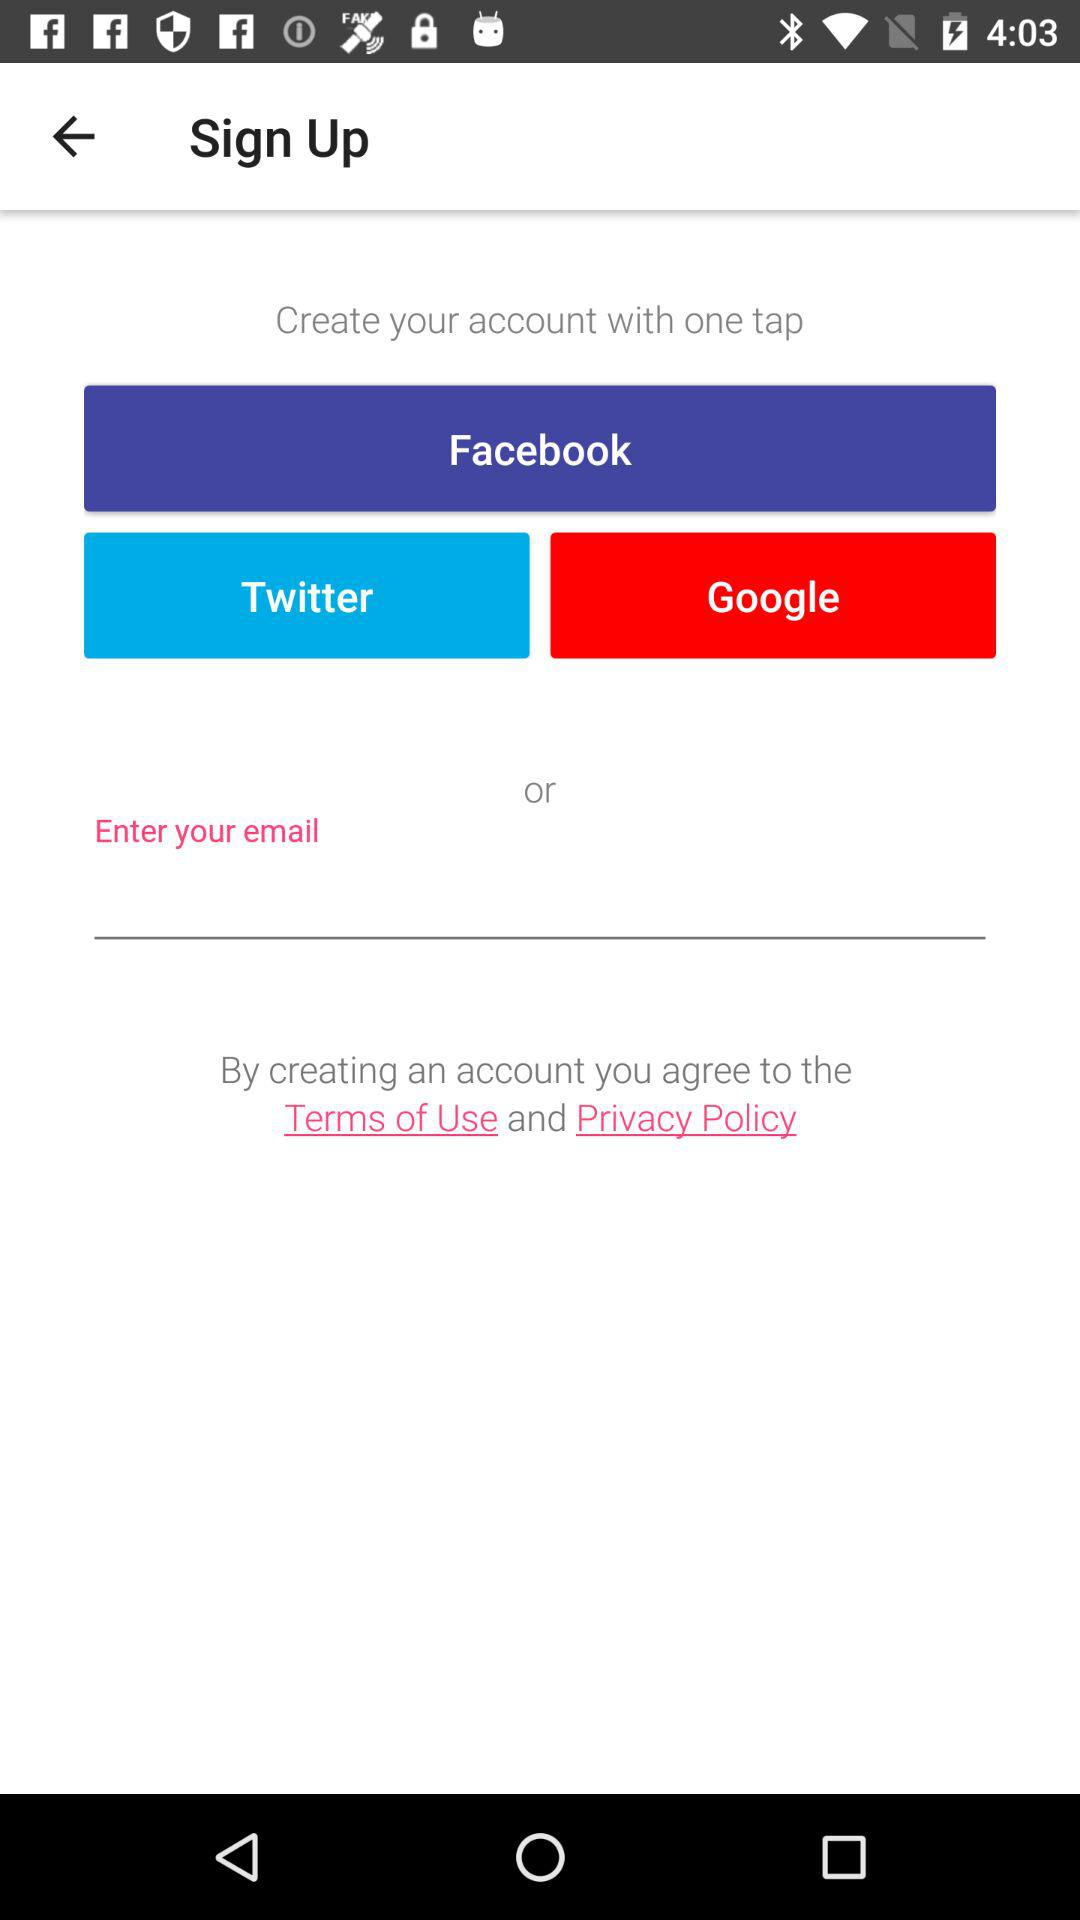Which option to create an account is selected?
When the provided information is insufficient, respond with <no answer>. <no answer> 